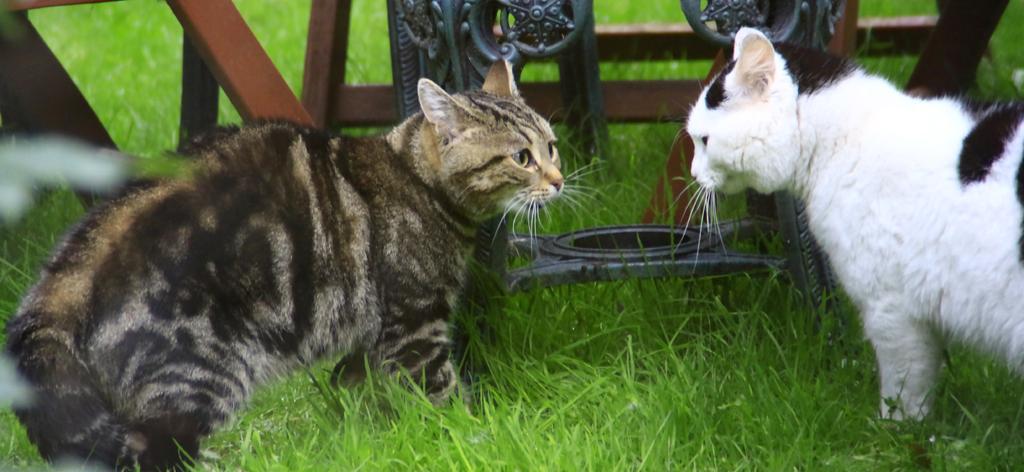Could you give a brief overview of what you see in this image? On the left side, there is cat in black and gray color combination, standing on the ground. On the right side, there is another cat in black and white color combination, standing on the ground on which there is grass. In the background, there are other objects arranged on the ground. 